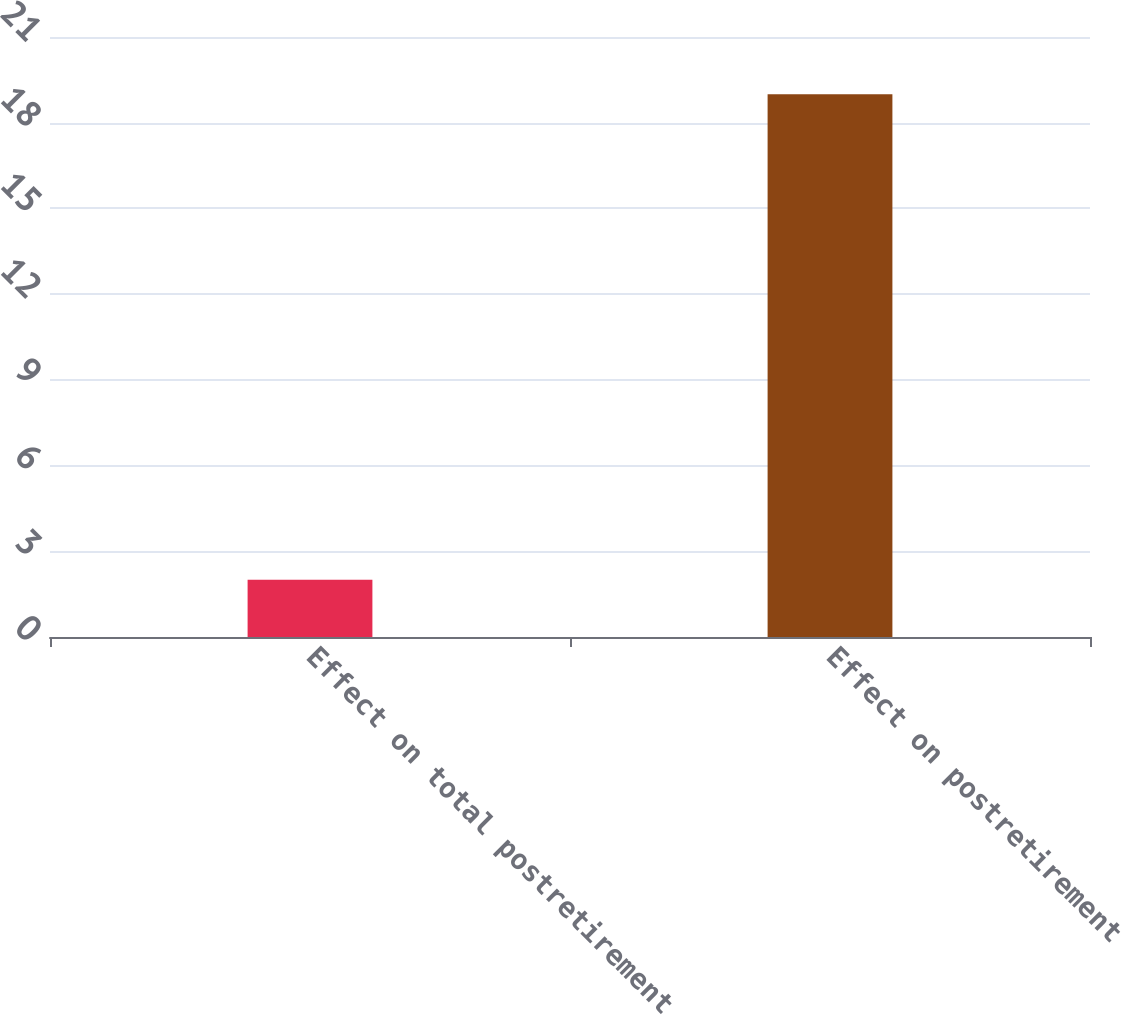Convert chart. <chart><loc_0><loc_0><loc_500><loc_500><bar_chart><fcel>Effect on total postretirement<fcel>Effect on postretirement<nl><fcel>2<fcel>19<nl></chart> 